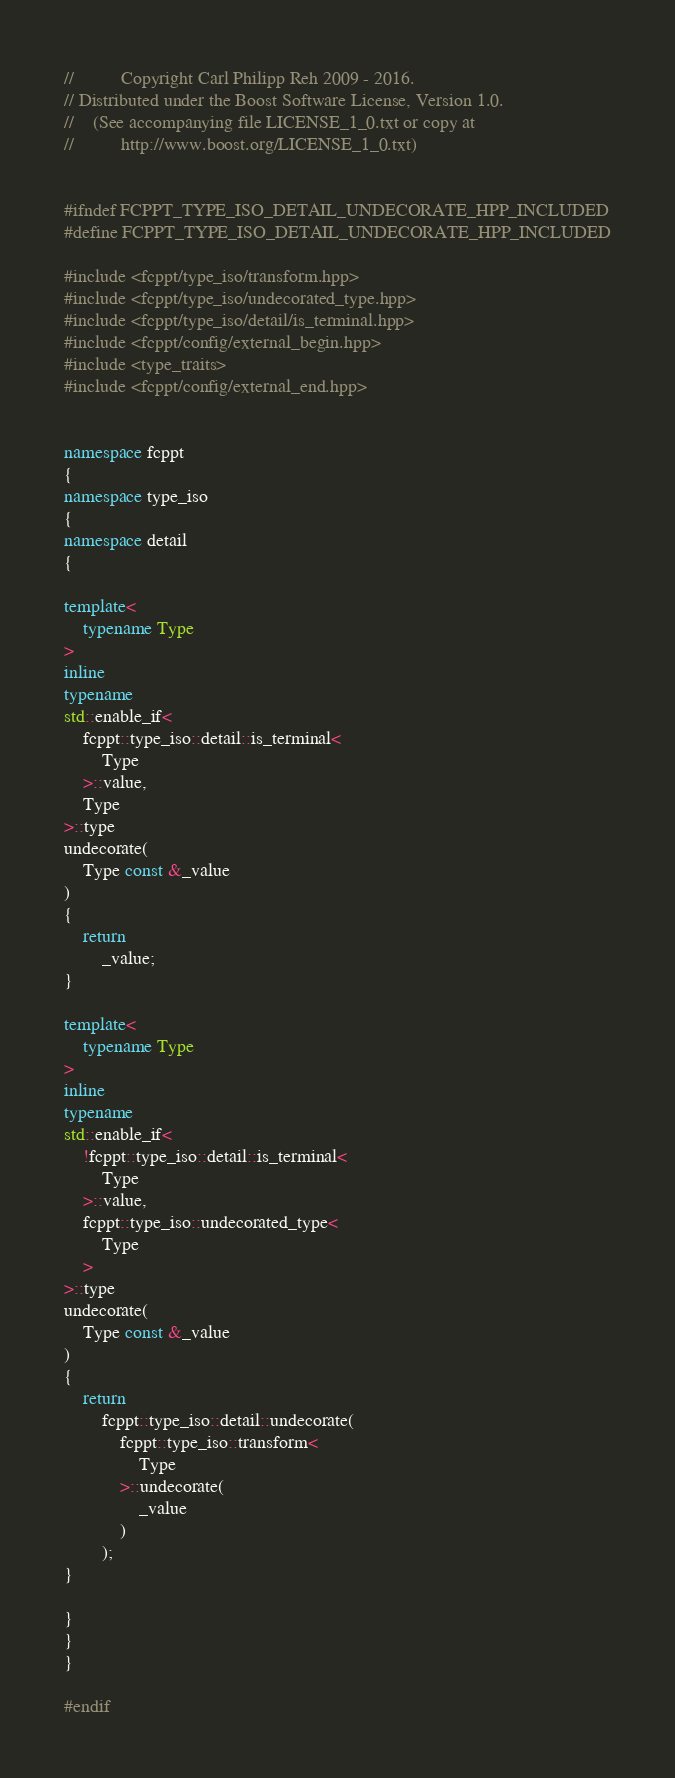Convert code to text. <code><loc_0><loc_0><loc_500><loc_500><_C++_>//          Copyright Carl Philipp Reh 2009 - 2016.
// Distributed under the Boost Software License, Version 1.0.
//    (See accompanying file LICENSE_1_0.txt or copy at
//          http://www.boost.org/LICENSE_1_0.txt)


#ifndef FCPPT_TYPE_ISO_DETAIL_UNDECORATE_HPP_INCLUDED
#define FCPPT_TYPE_ISO_DETAIL_UNDECORATE_HPP_INCLUDED

#include <fcppt/type_iso/transform.hpp>
#include <fcppt/type_iso/undecorated_type.hpp>
#include <fcppt/type_iso/detail/is_terminal.hpp>
#include <fcppt/config/external_begin.hpp>
#include <type_traits>
#include <fcppt/config/external_end.hpp>


namespace fcppt
{
namespace type_iso
{
namespace detail
{

template<
	typename Type
>
inline
typename
std::enable_if<
	fcppt::type_iso::detail::is_terminal<
		Type
	>::value,
	Type
>::type
undecorate(
	Type const &_value
)
{
	return
		_value;
}

template<
	typename Type
>
inline
typename
std::enable_if<
	!fcppt::type_iso::detail::is_terminal<
		Type
	>::value,
	fcppt::type_iso::undecorated_type<
		Type
	>
>::type
undecorate(
	Type const &_value
)
{
	return
		fcppt::type_iso::detail::undecorate(
			fcppt::type_iso::transform<
				Type
			>::undecorate(
				_value
			)
		);
}

}
}
}

#endif
</code> 